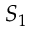Convert formula to latex. <formula><loc_0><loc_0><loc_500><loc_500>S _ { 1 }</formula> 